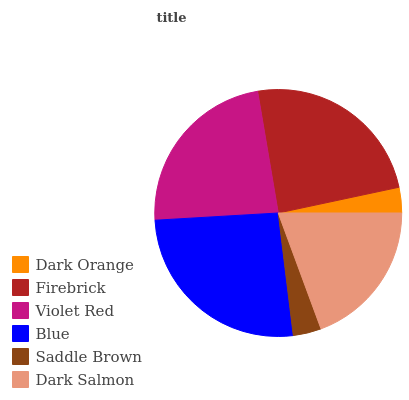Is Dark Orange the minimum?
Answer yes or no. Yes. Is Blue the maximum?
Answer yes or no. Yes. Is Firebrick the minimum?
Answer yes or no. No. Is Firebrick the maximum?
Answer yes or no. No. Is Firebrick greater than Dark Orange?
Answer yes or no. Yes. Is Dark Orange less than Firebrick?
Answer yes or no. Yes. Is Dark Orange greater than Firebrick?
Answer yes or no. No. Is Firebrick less than Dark Orange?
Answer yes or no. No. Is Violet Red the high median?
Answer yes or no. Yes. Is Dark Salmon the low median?
Answer yes or no. Yes. Is Firebrick the high median?
Answer yes or no. No. Is Dark Orange the low median?
Answer yes or no. No. 